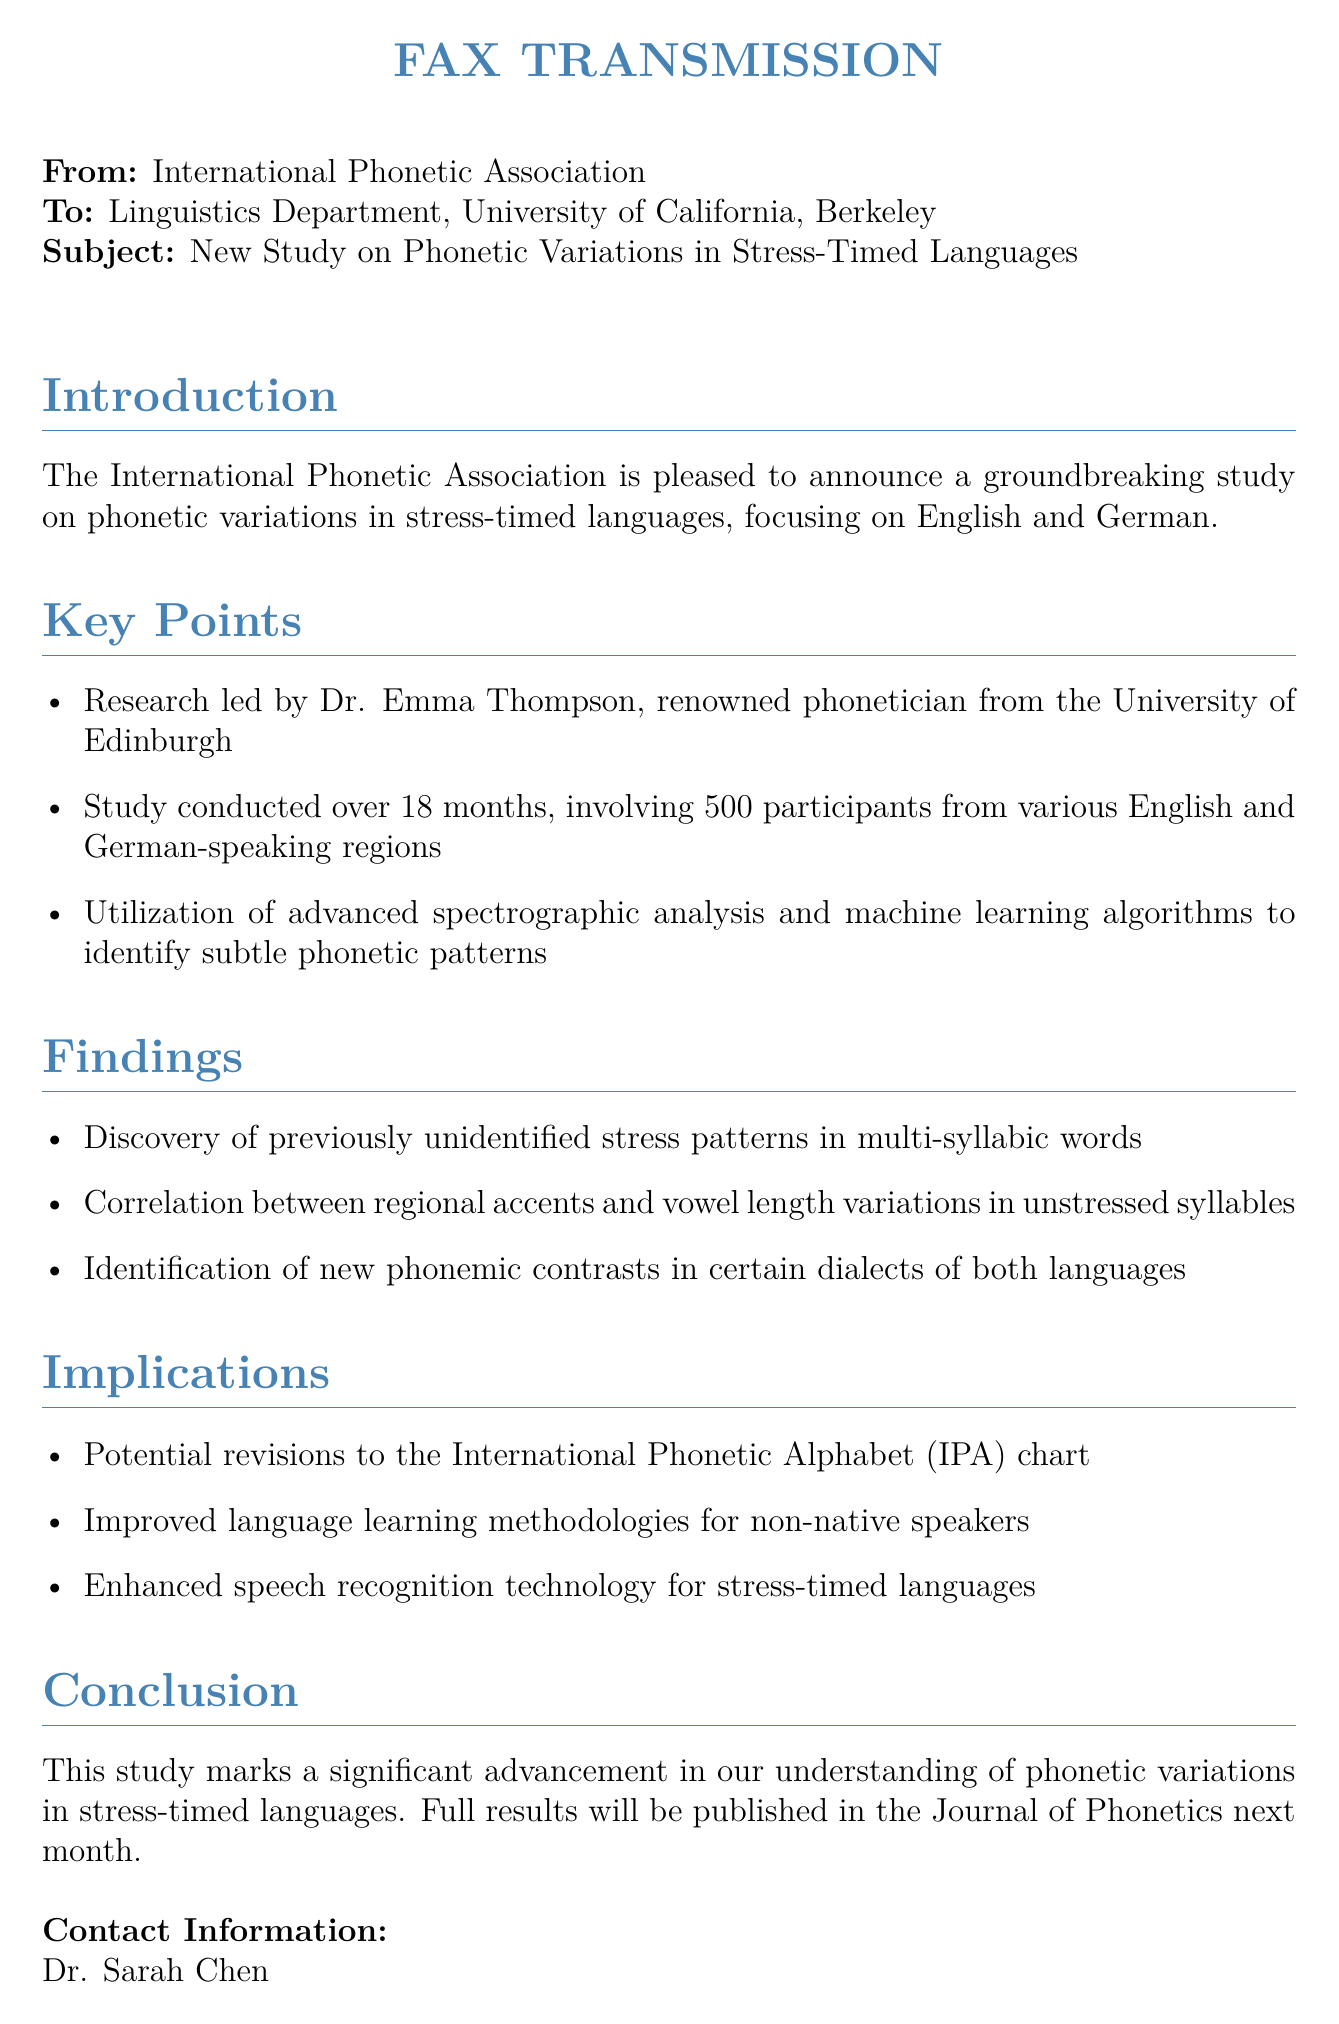What is the subject of the fax? The subject is specified in the header of the fax, which states it is a new study on phonetic variations in stress-timed languages.
Answer: New Study on Phonetic Variations in Stress-Timed Languages Who led the research? Dr. Emma Thompson is mentioned as the lead researcher in the key points section.
Answer: Dr. Emma Thompson How many participants were involved in the study? The number of participants is listed in the key points section.
Answer: 500 How long was the study conducted? The duration of the study is provided in the key points section.
Answer: 18 months What is one potential revision suggested by the study? The implications section discusses revisions to the International Phonetic Alphabet chart.
Answer: IPA chart Which two languages are the focus of the study? The introduction section clearly states the focus languages of the research.
Answer: English and German What advanced technology was utilized in the study? The key points section mentions the use of advanced spectrographic analysis and machine learning algorithms.
Answer: Machine learning algorithms When will the full results be published? The conclusion section provides information on the publication timeline of the study results.
Answer: Next month Who is the contact person for this study? The contact information section specifies the name of the research coordinator.
Answer: Dr. Sarah Chen 